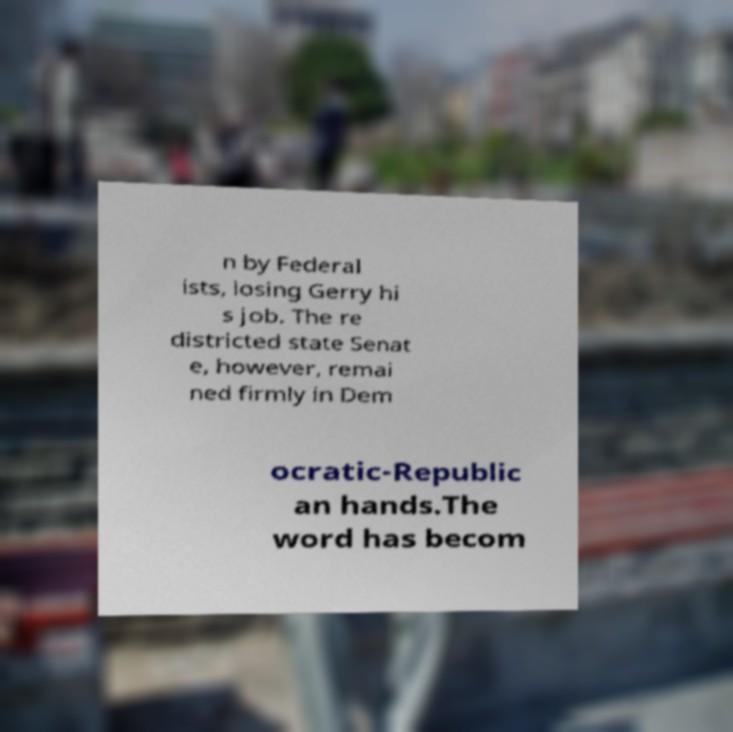Could you assist in decoding the text presented in this image and type it out clearly? n by Federal ists, losing Gerry hi s job. The re districted state Senat e, however, remai ned firmly in Dem ocratic-Republic an hands.The word has becom 